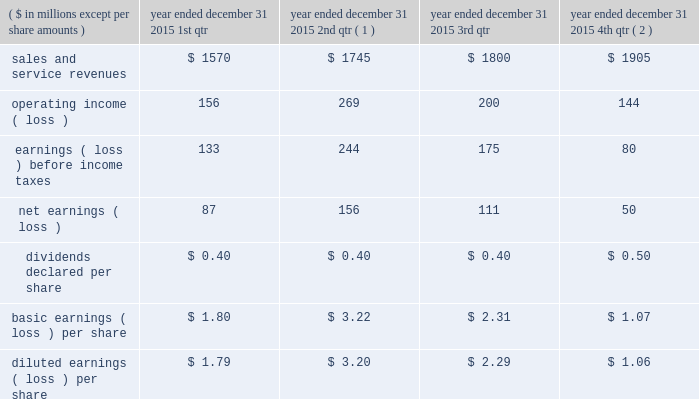Of exercise for stock options exercised or at period end for outstanding stock options , less the applicable exercise price .
The company issued new shares to satisfy exercised stock options .
Compensation expense the company recorded $ 43 million , $ 34 million , and $ 44 million of expense related to stock awards for the years ended december 31 , 2015 , 2014 , and 2013 , respectively .
The company recorded $ 17 million , $ 13 million , and $ 17 million as a tax benefit related to stock awards and stock options for the years ended december 31 , 2015 , 2014 , and 2013 , respectively .
The company recognized tax benefits for the years ended december 31 , 2015 , 2014 , and 2013 , of $ 41 million , $ 53 million , and $ 32 million , respectively , from the issuance of stock in settlement of stock awards , and $ 4 million , $ 5 million , and $ 4 million for the years ended december 31 , 2015 , 2014 , and 2013 , respectively , from the exercise of stock options .
Unrecognized compensation expense as of december 31 , 2015 , the company had less than $ 1 million of unrecognized compensation expense associated with rsrs granted in 2015 and 2014 , which will be recognized over a weighted average period of 1.0 year , and $ 25 million of unrecognized expense associated with rpsrs granted in 2015 , 2014 , and 2013 , which will be recognized over a weighted average period of 0.6 years .
As of december 31 , 2015 , the company had no unrecognized compensation expense related to stock options .
Compensation expense for stock options was fully recognized as of december 31 , 2013 .
20 .
Unaudited selected quarterly data unaudited quarterly financial results for the years ended december 31 , 2015 and 2014 , are set forth in the tables: .
( 1 ) in the second quarter of 2015 , the company recorded a $ 59 million goodwill impairment charge .
During the same period , the company recorded $ 136 million of operating income as a result of the aon settlement .
( 2 ) in the fourth quarter of 2015 , the company recorded $ 16 million goodwill impairment and $ 27 million intangible asset impairment charges. .
What is the total revenue for the fiscal year of 2015? 
Computations: (((1570 + 1745) + 1800) + 1905)
Answer: 7020.0. 